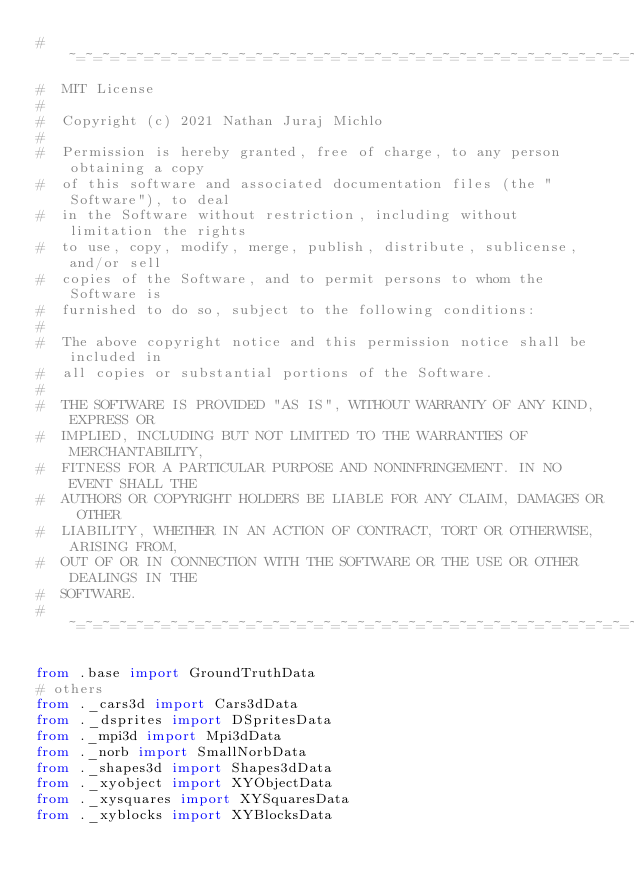Convert code to text. <code><loc_0><loc_0><loc_500><loc_500><_Python_>#  ~=~=~=~=~=~=~=~=~=~=~=~=~=~=~=~=~=~=~=~=~=~=~=~=~=~=~=~=~=~=~=~=~=~=~=~=~=~=~
#  MIT License
#
#  Copyright (c) 2021 Nathan Juraj Michlo
#
#  Permission is hereby granted, free of charge, to any person obtaining a copy
#  of this software and associated documentation files (the "Software"), to deal
#  in the Software without restriction, including without limitation the rights
#  to use, copy, modify, merge, publish, distribute, sublicense, and/or sell
#  copies of the Software, and to permit persons to whom the Software is
#  furnished to do so, subject to the following conditions:
#
#  The above copyright notice and this permission notice shall be included in
#  all copies or substantial portions of the Software.
#
#  THE SOFTWARE IS PROVIDED "AS IS", WITHOUT WARRANTY OF ANY KIND, EXPRESS OR
#  IMPLIED, INCLUDING BUT NOT LIMITED TO THE WARRANTIES OF MERCHANTABILITY,
#  FITNESS FOR A PARTICULAR PURPOSE AND NONINFRINGEMENT. IN NO EVENT SHALL THE
#  AUTHORS OR COPYRIGHT HOLDERS BE LIABLE FOR ANY CLAIM, DAMAGES OR OTHER
#  LIABILITY, WHETHER IN AN ACTION OF CONTRACT, TORT OR OTHERWISE, ARISING FROM,
#  OUT OF OR IN CONNECTION WITH THE SOFTWARE OR THE USE OR OTHER DEALINGS IN THE
#  SOFTWARE.
#  ~=~=~=~=~=~=~=~=~=~=~=~=~=~=~=~=~=~=~=~=~=~=~=~=~=~=~=~=~=~=~=~=~=~=~=~=~=~=~

from .base import GroundTruthData
# others
from ._cars3d import Cars3dData
from ._dsprites import DSpritesData
from ._mpi3d import Mpi3dData
from ._norb import SmallNorbData
from ._shapes3d import Shapes3dData
from ._xyobject import XYObjectData
from ._xysquares import XYSquaresData
from ._xyblocks import XYBlocksData
</code> 